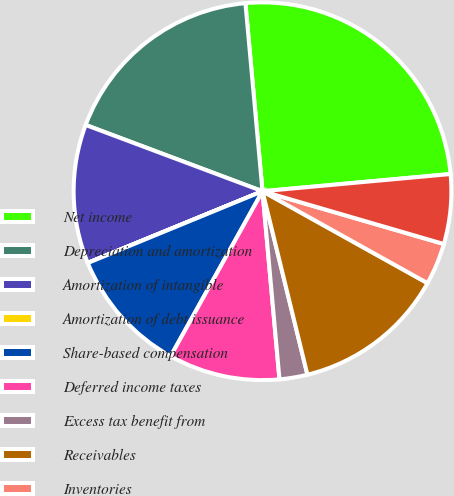Convert chart. <chart><loc_0><loc_0><loc_500><loc_500><pie_chart><fcel>Net income<fcel>Depreciation and amortization<fcel>Amortization of intangible<fcel>Amortization of debt issuance<fcel>Share-based compensation<fcel>Deferred income taxes<fcel>Excess tax benefit from<fcel>Receivables<fcel>Inventories<fcel>Trade accounts payable<nl><fcel>24.99%<fcel>17.85%<fcel>11.9%<fcel>0.01%<fcel>10.71%<fcel>9.52%<fcel>2.39%<fcel>13.09%<fcel>3.58%<fcel>5.96%<nl></chart> 